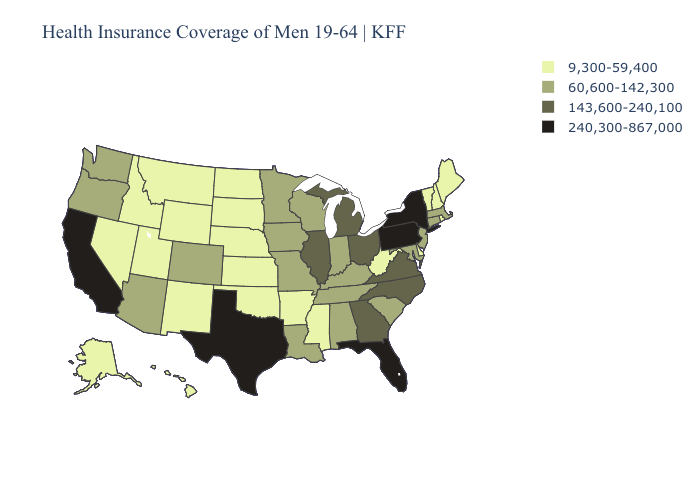Which states hav the highest value in the West?
Concise answer only. California. Does Oklahoma have the highest value in the USA?
Concise answer only. No. What is the value of South Dakota?
Concise answer only. 9,300-59,400. What is the value of Louisiana?
Write a very short answer. 60,600-142,300. Name the states that have a value in the range 9,300-59,400?
Give a very brief answer. Alaska, Arkansas, Delaware, Hawaii, Idaho, Kansas, Maine, Mississippi, Montana, Nebraska, Nevada, New Hampshire, New Mexico, North Dakota, Oklahoma, Rhode Island, South Dakota, Utah, Vermont, West Virginia, Wyoming. Name the states that have a value in the range 240,300-867,000?
Answer briefly. California, Florida, New York, Pennsylvania, Texas. What is the value of Minnesota?
Give a very brief answer. 60,600-142,300. Which states have the lowest value in the West?
Give a very brief answer. Alaska, Hawaii, Idaho, Montana, Nevada, New Mexico, Utah, Wyoming. Does Oklahoma have the highest value in the USA?
Answer briefly. No. What is the highest value in the West ?
Give a very brief answer. 240,300-867,000. What is the value of Michigan?
Quick response, please. 143,600-240,100. What is the highest value in the South ?
Give a very brief answer. 240,300-867,000. Does the map have missing data?
Answer briefly. No. Does Nevada have a lower value than Connecticut?
Write a very short answer. Yes. 